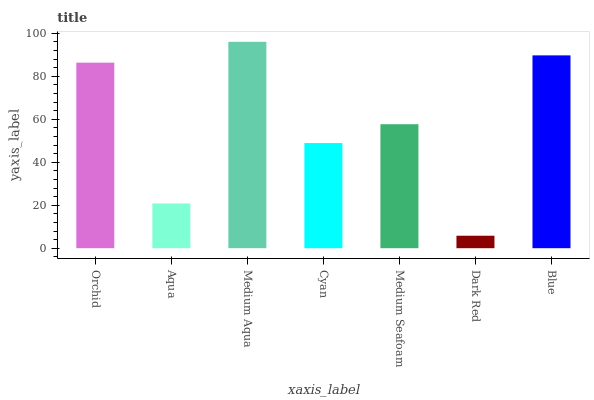Is Dark Red the minimum?
Answer yes or no. Yes. Is Medium Aqua the maximum?
Answer yes or no. Yes. Is Aqua the minimum?
Answer yes or no. No. Is Aqua the maximum?
Answer yes or no. No. Is Orchid greater than Aqua?
Answer yes or no. Yes. Is Aqua less than Orchid?
Answer yes or no. Yes. Is Aqua greater than Orchid?
Answer yes or no. No. Is Orchid less than Aqua?
Answer yes or no. No. Is Medium Seafoam the high median?
Answer yes or no. Yes. Is Medium Seafoam the low median?
Answer yes or no. Yes. Is Medium Aqua the high median?
Answer yes or no. No. Is Aqua the low median?
Answer yes or no. No. 